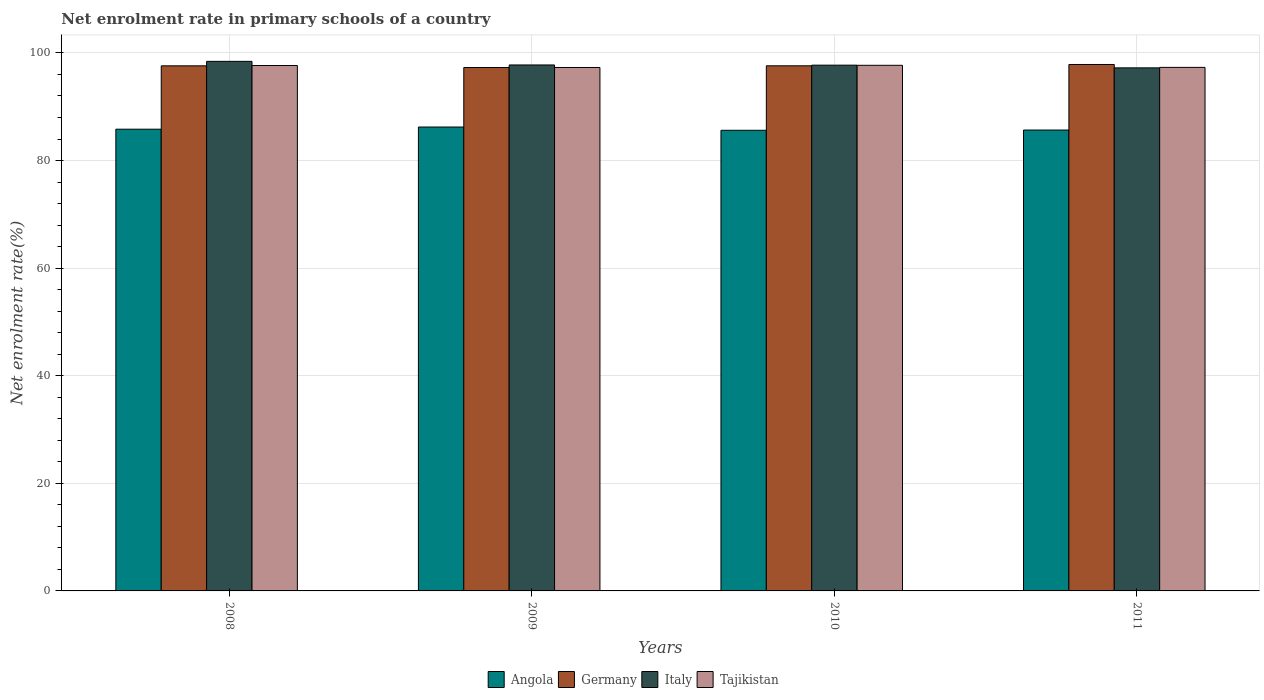How many different coloured bars are there?
Provide a short and direct response. 4. Are the number of bars per tick equal to the number of legend labels?
Your response must be concise. Yes. Are the number of bars on each tick of the X-axis equal?
Provide a short and direct response. Yes. How many bars are there on the 4th tick from the left?
Provide a short and direct response. 4. How many bars are there on the 1st tick from the right?
Your response must be concise. 4. What is the net enrolment rate in primary schools in Italy in 2011?
Offer a terse response. 97.22. Across all years, what is the maximum net enrolment rate in primary schools in Germany?
Offer a terse response. 97.85. Across all years, what is the minimum net enrolment rate in primary schools in Tajikistan?
Your answer should be compact. 97.29. In which year was the net enrolment rate in primary schools in Tajikistan minimum?
Your answer should be very brief. 2009. What is the total net enrolment rate in primary schools in Angola in the graph?
Your response must be concise. 343.34. What is the difference between the net enrolment rate in primary schools in Tajikistan in 2010 and that in 2011?
Ensure brevity in your answer.  0.39. What is the difference between the net enrolment rate in primary schools in Tajikistan in 2008 and the net enrolment rate in primary schools in Angola in 2010?
Keep it short and to the point. 12.04. What is the average net enrolment rate in primary schools in Italy per year?
Your answer should be very brief. 97.79. In the year 2009, what is the difference between the net enrolment rate in primary schools in Italy and net enrolment rate in primary schools in Germany?
Your answer should be compact. 0.48. In how many years, is the net enrolment rate in primary schools in Italy greater than 36 %?
Your response must be concise. 4. What is the ratio of the net enrolment rate in primary schools in Italy in 2008 to that in 2011?
Give a very brief answer. 1.01. Is the net enrolment rate in primary schools in Italy in 2009 less than that in 2010?
Offer a very short reply. No. What is the difference between the highest and the second highest net enrolment rate in primary schools in Tajikistan?
Your response must be concise. 0.04. What is the difference between the highest and the lowest net enrolment rate in primary schools in Tajikistan?
Your response must be concise. 0.41. In how many years, is the net enrolment rate in primary schools in Germany greater than the average net enrolment rate in primary schools in Germany taken over all years?
Your response must be concise. 3. Is the sum of the net enrolment rate in primary schools in Tajikistan in 2010 and 2011 greater than the maximum net enrolment rate in primary schools in Angola across all years?
Offer a very short reply. Yes. Is it the case that in every year, the sum of the net enrolment rate in primary schools in Tajikistan and net enrolment rate in primary schools in Italy is greater than the sum of net enrolment rate in primary schools in Angola and net enrolment rate in primary schools in Germany?
Make the answer very short. No. What does the 4th bar from the left in 2009 represents?
Give a very brief answer. Tajikistan. What does the 2nd bar from the right in 2009 represents?
Give a very brief answer. Italy. Is it the case that in every year, the sum of the net enrolment rate in primary schools in Tajikistan and net enrolment rate in primary schools in Angola is greater than the net enrolment rate in primary schools in Germany?
Provide a short and direct response. Yes. What is the difference between two consecutive major ticks on the Y-axis?
Offer a very short reply. 20. Are the values on the major ticks of Y-axis written in scientific E-notation?
Your response must be concise. No. Does the graph contain any zero values?
Your answer should be very brief. No. How many legend labels are there?
Offer a very short reply. 4. How are the legend labels stacked?
Provide a short and direct response. Horizontal. What is the title of the graph?
Your response must be concise. Net enrolment rate in primary schools of a country. Does "Honduras" appear as one of the legend labels in the graph?
Ensure brevity in your answer.  No. What is the label or title of the X-axis?
Make the answer very short. Years. What is the label or title of the Y-axis?
Offer a very short reply. Net enrolment rate(%). What is the Net enrolment rate(%) of Angola in 2008?
Provide a succinct answer. 85.82. What is the Net enrolment rate(%) of Germany in 2008?
Offer a terse response. 97.6. What is the Net enrolment rate(%) in Italy in 2008?
Offer a very short reply. 98.44. What is the Net enrolment rate(%) in Tajikistan in 2008?
Your response must be concise. 97.66. What is the Net enrolment rate(%) in Angola in 2009?
Provide a short and direct response. 86.23. What is the Net enrolment rate(%) of Germany in 2009?
Keep it short and to the point. 97.29. What is the Net enrolment rate(%) of Italy in 2009?
Keep it short and to the point. 97.76. What is the Net enrolment rate(%) in Tajikistan in 2009?
Give a very brief answer. 97.29. What is the Net enrolment rate(%) in Angola in 2010?
Provide a succinct answer. 85.62. What is the Net enrolment rate(%) of Germany in 2010?
Your response must be concise. 97.61. What is the Net enrolment rate(%) of Italy in 2010?
Provide a succinct answer. 97.73. What is the Net enrolment rate(%) of Tajikistan in 2010?
Provide a short and direct response. 97.7. What is the Net enrolment rate(%) of Angola in 2011?
Your response must be concise. 85.67. What is the Net enrolment rate(%) of Germany in 2011?
Offer a very short reply. 97.85. What is the Net enrolment rate(%) of Italy in 2011?
Keep it short and to the point. 97.22. What is the Net enrolment rate(%) of Tajikistan in 2011?
Provide a short and direct response. 97.31. Across all years, what is the maximum Net enrolment rate(%) of Angola?
Your response must be concise. 86.23. Across all years, what is the maximum Net enrolment rate(%) in Germany?
Your answer should be compact. 97.85. Across all years, what is the maximum Net enrolment rate(%) of Italy?
Ensure brevity in your answer.  98.44. Across all years, what is the maximum Net enrolment rate(%) in Tajikistan?
Make the answer very short. 97.7. Across all years, what is the minimum Net enrolment rate(%) of Angola?
Your answer should be compact. 85.62. Across all years, what is the minimum Net enrolment rate(%) of Germany?
Your response must be concise. 97.29. Across all years, what is the minimum Net enrolment rate(%) in Italy?
Your response must be concise. 97.22. Across all years, what is the minimum Net enrolment rate(%) in Tajikistan?
Keep it short and to the point. 97.29. What is the total Net enrolment rate(%) in Angola in the graph?
Keep it short and to the point. 343.34. What is the total Net enrolment rate(%) in Germany in the graph?
Offer a very short reply. 390.35. What is the total Net enrolment rate(%) in Italy in the graph?
Keep it short and to the point. 391.15. What is the total Net enrolment rate(%) of Tajikistan in the graph?
Give a very brief answer. 389.97. What is the difference between the Net enrolment rate(%) in Angola in 2008 and that in 2009?
Your response must be concise. -0.4. What is the difference between the Net enrolment rate(%) in Germany in 2008 and that in 2009?
Make the answer very short. 0.32. What is the difference between the Net enrolment rate(%) of Italy in 2008 and that in 2009?
Your answer should be very brief. 0.67. What is the difference between the Net enrolment rate(%) of Tajikistan in 2008 and that in 2009?
Your answer should be compact. 0.37. What is the difference between the Net enrolment rate(%) in Angola in 2008 and that in 2010?
Your answer should be compact. 0.2. What is the difference between the Net enrolment rate(%) in Germany in 2008 and that in 2010?
Your answer should be compact. -0. What is the difference between the Net enrolment rate(%) of Italy in 2008 and that in 2010?
Offer a terse response. 0.71. What is the difference between the Net enrolment rate(%) of Tajikistan in 2008 and that in 2010?
Your answer should be very brief. -0.04. What is the difference between the Net enrolment rate(%) in Angola in 2008 and that in 2011?
Ensure brevity in your answer.  0.16. What is the difference between the Net enrolment rate(%) of Germany in 2008 and that in 2011?
Provide a short and direct response. -0.25. What is the difference between the Net enrolment rate(%) of Italy in 2008 and that in 2011?
Give a very brief answer. 1.21. What is the difference between the Net enrolment rate(%) of Tajikistan in 2008 and that in 2011?
Give a very brief answer. 0.35. What is the difference between the Net enrolment rate(%) in Angola in 2009 and that in 2010?
Your answer should be very brief. 0.61. What is the difference between the Net enrolment rate(%) in Germany in 2009 and that in 2010?
Your answer should be compact. -0.32. What is the difference between the Net enrolment rate(%) in Italy in 2009 and that in 2010?
Make the answer very short. 0.04. What is the difference between the Net enrolment rate(%) of Tajikistan in 2009 and that in 2010?
Keep it short and to the point. -0.41. What is the difference between the Net enrolment rate(%) of Angola in 2009 and that in 2011?
Your answer should be compact. 0.56. What is the difference between the Net enrolment rate(%) of Germany in 2009 and that in 2011?
Make the answer very short. -0.57. What is the difference between the Net enrolment rate(%) of Italy in 2009 and that in 2011?
Your answer should be very brief. 0.54. What is the difference between the Net enrolment rate(%) of Tajikistan in 2009 and that in 2011?
Offer a terse response. -0.02. What is the difference between the Net enrolment rate(%) in Angola in 2010 and that in 2011?
Keep it short and to the point. -0.05. What is the difference between the Net enrolment rate(%) of Germany in 2010 and that in 2011?
Keep it short and to the point. -0.24. What is the difference between the Net enrolment rate(%) in Italy in 2010 and that in 2011?
Ensure brevity in your answer.  0.5. What is the difference between the Net enrolment rate(%) in Tajikistan in 2010 and that in 2011?
Give a very brief answer. 0.39. What is the difference between the Net enrolment rate(%) in Angola in 2008 and the Net enrolment rate(%) in Germany in 2009?
Provide a succinct answer. -11.46. What is the difference between the Net enrolment rate(%) in Angola in 2008 and the Net enrolment rate(%) in Italy in 2009?
Your answer should be very brief. -11.94. What is the difference between the Net enrolment rate(%) in Angola in 2008 and the Net enrolment rate(%) in Tajikistan in 2009?
Offer a terse response. -11.47. What is the difference between the Net enrolment rate(%) in Germany in 2008 and the Net enrolment rate(%) in Italy in 2009?
Keep it short and to the point. -0.16. What is the difference between the Net enrolment rate(%) of Germany in 2008 and the Net enrolment rate(%) of Tajikistan in 2009?
Your answer should be compact. 0.31. What is the difference between the Net enrolment rate(%) of Italy in 2008 and the Net enrolment rate(%) of Tajikistan in 2009?
Offer a very short reply. 1.14. What is the difference between the Net enrolment rate(%) of Angola in 2008 and the Net enrolment rate(%) of Germany in 2010?
Your response must be concise. -11.78. What is the difference between the Net enrolment rate(%) of Angola in 2008 and the Net enrolment rate(%) of Italy in 2010?
Offer a very short reply. -11.9. What is the difference between the Net enrolment rate(%) of Angola in 2008 and the Net enrolment rate(%) of Tajikistan in 2010?
Provide a short and direct response. -11.88. What is the difference between the Net enrolment rate(%) of Germany in 2008 and the Net enrolment rate(%) of Italy in 2010?
Keep it short and to the point. -0.12. What is the difference between the Net enrolment rate(%) in Germany in 2008 and the Net enrolment rate(%) in Tajikistan in 2010?
Offer a very short reply. -0.1. What is the difference between the Net enrolment rate(%) in Italy in 2008 and the Net enrolment rate(%) in Tajikistan in 2010?
Your answer should be very brief. 0.74. What is the difference between the Net enrolment rate(%) in Angola in 2008 and the Net enrolment rate(%) in Germany in 2011?
Offer a terse response. -12.03. What is the difference between the Net enrolment rate(%) of Angola in 2008 and the Net enrolment rate(%) of Italy in 2011?
Your answer should be very brief. -11.4. What is the difference between the Net enrolment rate(%) in Angola in 2008 and the Net enrolment rate(%) in Tajikistan in 2011?
Give a very brief answer. -11.49. What is the difference between the Net enrolment rate(%) in Germany in 2008 and the Net enrolment rate(%) in Italy in 2011?
Keep it short and to the point. 0.38. What is the difference between the Net enrolment rate(%) in Germany in 2008 and the Net enrolment rate(%) in Tajikistan in 2011?
Keep it short and to the point. 0.29. What is the difference between the Net enrolment rate(%) of Italy in 2008 and the Net enrolment rate(%) of Tajikistan in 2011?
Ensure brevity in your answer.  1.12. What is the difference between the Net enrolment rate(%) of Angola in 2009 and the Net enrolment rate(%) of Germany in 2010?
Keep it short and to the point. -11.38. What is the difference between the Net enrolment rate(%) of Angola in 2009 and the Net enrolment rate(%) of Italy in 2010?
Keep it short and to the point. -11.5. What is the difference between the Net enrolment rate(%) in Angola in 2009 and the Net enrolment rate(%) in Tajikistan in 2010?
Your answer should be compact. -11.47. What is the difference between the Net enrolment rate(%) of Germany in 2009 and the Net enrolment rate(%) of Italy in 2010?
Your answer should be very brief. -0.44. What is the difference between the Net enrolment rate(%) in Germany in 2009 and the Net enrolment rate(%) in Tajikistan in 2010?
Your answer should be compact. -0.41. What is the difference between the Net enrolment rate(%) in Italy in 2009 and the Net enrolment rate(%) in Tajikistan in 2010?
Provide a succinct answer. 0.06. What is the difference between the Net enrolment rate(%) in Angola in 2009 and the Net enrolment rate(%) in Germany in 2011?
Provide a succinct answer. -11.62. What is the difference between the Net enrolment rate(%) in Angola in 2009 and the Net enrolment rate(%) in Italy in 2011?
Provide a short and direct response. -10.99. What is the difference between the Net enrolment rate(%) of Angola in 2009 and the Net enrolment rate(%) of Tajikistan in 2011?
Offer a very short reply. -11.08. What is the difference between the Net enrolment rate(%) of Germany in 2009 and the Net enrolment rate(%) of Italy in 2011?
Ensure brevity in your answer.  0.06. What is the difference between the Net enrolment rate(%) of Germany in 2009 and the Net enrolment rate(%) of Tajikistan in 2011?
Ensure brevity in your answer.  -0.03. What is the difference between the Net enrolment rate(%) of Italy in 2009 and the Net enrolment rate(%) of Tajikistan in 2011?
Keep it short and to the point. 0.45. What is the difference between the Net enrolment rate(%) of Angola in 2010 and the Net enrolment rate(%) of Germany in 2011?
Provide a short and direct response. -12.23. What is the difference between the Net enrolment rate(%) of Angola in 2010 and the Net enrolment rate(%) of Italy in 2011?
Your answer should be compact. -11.6. What is the difference between the Net enrolment rate(%) of Angola in 2010 and the Net enrolment rate(%) of Tajikistan in 2011?
Ensure brevity in your answer.  -11.69. What is the difference between the Net enrolment rate(%) in Germany in 2010 and the Net enrolment rate(%) in Italy in 2011?
Provide a short and direct response. 0.38. What is the difference between the Net enrolment rate(%) of Germany in 2010 and the Net enrolment rate(%) of Tajikistan in 2011?
Offer a very short reply. 0.29. What is the difference between the Net enrolment rate(%) of Italy in 2010 and the Net enrolment rate(%) of Tajikistan in 2011?
Your response must be concise. 0.41. What is the average Net enrolment rate(%) of Angola per year?
Provide a short and direct response. 85.84. What is the average Net enrolment rate(%) of Germany per year?
Keep it short and to the point. 97.59. What is the average Net enrolment rate(%) of Italy per year?
Offer a very short reply. 97.79. What is the average Net enrolment rate(%) of Tajikistan per year?
Ensure brevity in your answer.  97.49. In the year 2008, what is the difference between the Net enrolment rate(%) in Angola and Net enrolment rate(%) in Germany?
Make the answer very short. -11.78. In the year 2008, what is the difference between the Net enrolment rate(%) in Angola and Net enrolment rate(%) in Italy?
Ensure brevity in your answer.  -12.61. In the year 2008, what is the difference between the Net enrolment rate(%) in Angola and Net enrolment rate(%) in Tajikistan?
Offer a very short reply. -11.84. In the year 2008, what is the difference between the Net enrolment rate(%) in Germany and Net enrolment rate(%) in Italy?
Your answer should be very brief. -0.83. In the year 2008, what is the difference between the Net enrolment rate(%) of Germany and Net enrolment rate(%) of Tajikistan?
Offer a terse response. -0.06. In the year 2008, what is the difference between the Net enrolment rate(%) in Italy and Net enrolment rate(%) in Tajikistan?
Your answer should be compact. 0.77. In the year 2009, what is the difference between the Net enrolment rate(%) in Angola and Net enrolment rate(%) in Germany?
Give a very brief answer. -11.06. In the year 2009, what is the difference between the Net enrolment rate(%) in Angola and Net enrolment rate(%) in Italy?
Your answer should be compact. -11.53. In the year 2009, what is the difference between the Net enrolment rate(%) in Angola and Net enrolment rate(%) in Tajikistan?
Your answer should be compact. -11.06. In the year 2009, what is the difference between the Net enrolment rate(%) of Germany and Net enrolment rate(%) of Italy?
Make the answer very short. -0.48. In the year 2009, what is the difference between the Net enrolment rate(%) of Germany and Net enrolment rate(%) of Tajikistan?
Offer a terse response. -0.01. In the year 2009, what is the difference between the Net enrolment rate(%) of Italy and Net enrolment rate(%) of Tajikistan?
Offer a very short reply. 0.47. In the year 2010, what is the difference between the Net enrolment rate(%) in Angola and Net enrolment rate(%) in Germany?
Ensure brevity in your answer.  -11.99. In the year 2010, what is the difference between the Net enrolment rate(%) of Angola and Net enrolment rate(%) of Italy?
Provide a short and direct response. -12.11. In the year 2010, what is the difference between the Net enrolment rate(%) in Angola and Net enrolment rate(%) in Tajikistan?
Your response must be concise. -12.08. In the year 2010, what is the difference between the Net enrolment rate(%) of Germany and Net enrolment rate(%) of Italy?
Ensure brevity in your answer.  -0.12. In the year 2010, what is the difference between the Net enrolment rate(%) in Germany and Net enrolment rate(%) in Tajikistan?
Offer a very short reply. -0.09. In the year 2010, what is the difference between the Net enrolment rate(%) in Italy and Net enrolment rate(%) in Tajikistan?
Your answer should be very brief. 0.03. In the year 2011, what is the difference between the Net enrolment rate(%) in Angola and Net enrolment rate(%) in Germany?
Provide a succinct answer. -12.18. In the year 2011, what is the difference between the Net enrolment rate(%) of Angola and Net enrolment rate(%) of Italy?
Provide a short and direct response. -11.56. In the year 2011, what is the difference between the Net enrolment rate(%) in Angola and Net enrolment rate(%) in Tajikistan?
Provide a succinct answer. -11.65. In the year 2011, what is the difference between the Net enrolment rate(%) of Germany and Net enrolment rate(%) of Italy?
Your answer should be compact. 0.63. In the year 2011, what is the difference between the Net enrolment rate(%) of Germany and Net enrolment rate(%) of Tajikistan?
Your answer should be very brief. 0.54. In the year 2011, what is the difference between the Net enrolment rate(%) of Italy and Net enrolment rate(%) of Tajikistan?
Provide a succinct answer. -0.09. What is the ratio of the Net enrolment rate(%) of Angola in 2008 to that in 2009?
Keep it short and to the point. 1. What is the ratio of the Net enrolment rate(%) of Germany in 2008 to that in 2009?
Give a very brief answer. 1. What is the ratio of the Net enrolment rate(%) of Italy in 2008 to that in 2009?
Keep it short and to the point. 1.01. What is the ratio of the Net enrolment rate(%) in Tajikistan in 2008 to that in 2009?
Your answer should be compact. 1. What is the ratio of the Net enrolment rate(%) of Italy in 2008 to that in 2010?
Your answer should be very brief. 1.01. What is the ratio of the Net enrolment rate(%) in Tajikistan in 2008 to that in 2010?
Provide a succinct answer. 1. What is the ratio of the Net enrolment rate(%) in Germany in 2008 to that in 2011?
Your answer should be very brief. 1. What is the ratio of the Net enrolment rate(%) in Italy in 2008 to that in 2011?
Provide a short and direct response. 1.01. What is the ratio of the Net enrolment rate(%) in Tajikistan in 2008 to that in 2011?
Provide a succinct answer. 1. What is the ratio of the Net enrolment rate(%) in Angola in 2009 to that in 2010?
Your answer should be compact. 1.01. What is the ratio of the Net enrolment rate(%) of Germany in 2009 to that in 2010?
Provide a short and direct response. 1. What is the ratio of the Net enrolment rate(%) of Italy in 2009 to that in 2011?
Offer a terse response. 1.01. What is the ratio of the Net enrolment rate(%) of Angola in 2010 to that in 2011?
Offer a very short reply. 1. What is the ratio of the Net enrolment rate(%) in Italy in 2010 to that in 2011?
Your answer should be compact. 1.01. What is the difference between the highest and the second highest Net enrolment rate(%) of Angola?
Provide a succinct answer. 0.4. What is the difference between the highest and the second highest Net enrolment rate(%) of Germany?
Keep it short and to the point. 0.24. What is the difference between the highest and the second highest Net enrolment rate(%) in Italy?
Ensure brevity in your answer.  0.67. What is the difference between the highest and the second highest Net enrolment rate(%) in Tajikistan?
Provide a succinct answer. 0.04. What is the difference between the highest and the lowest Net enrolment rate(%) in Angola?
Your answer should be very brief. 0.61. What is the difference between the highest and the lowest Net enrolment rate(%) in Germany?
Give a very brief answer. 0.57. What is the difference between the highest and the lowest Net enrolment rate(%) of Italy?
Ensure brevity in your answer.  1.21. What is the difference between the highest and the lowest Net enrolment rate(%) of Tajikistan?
Offer a terse response. 0.41. 